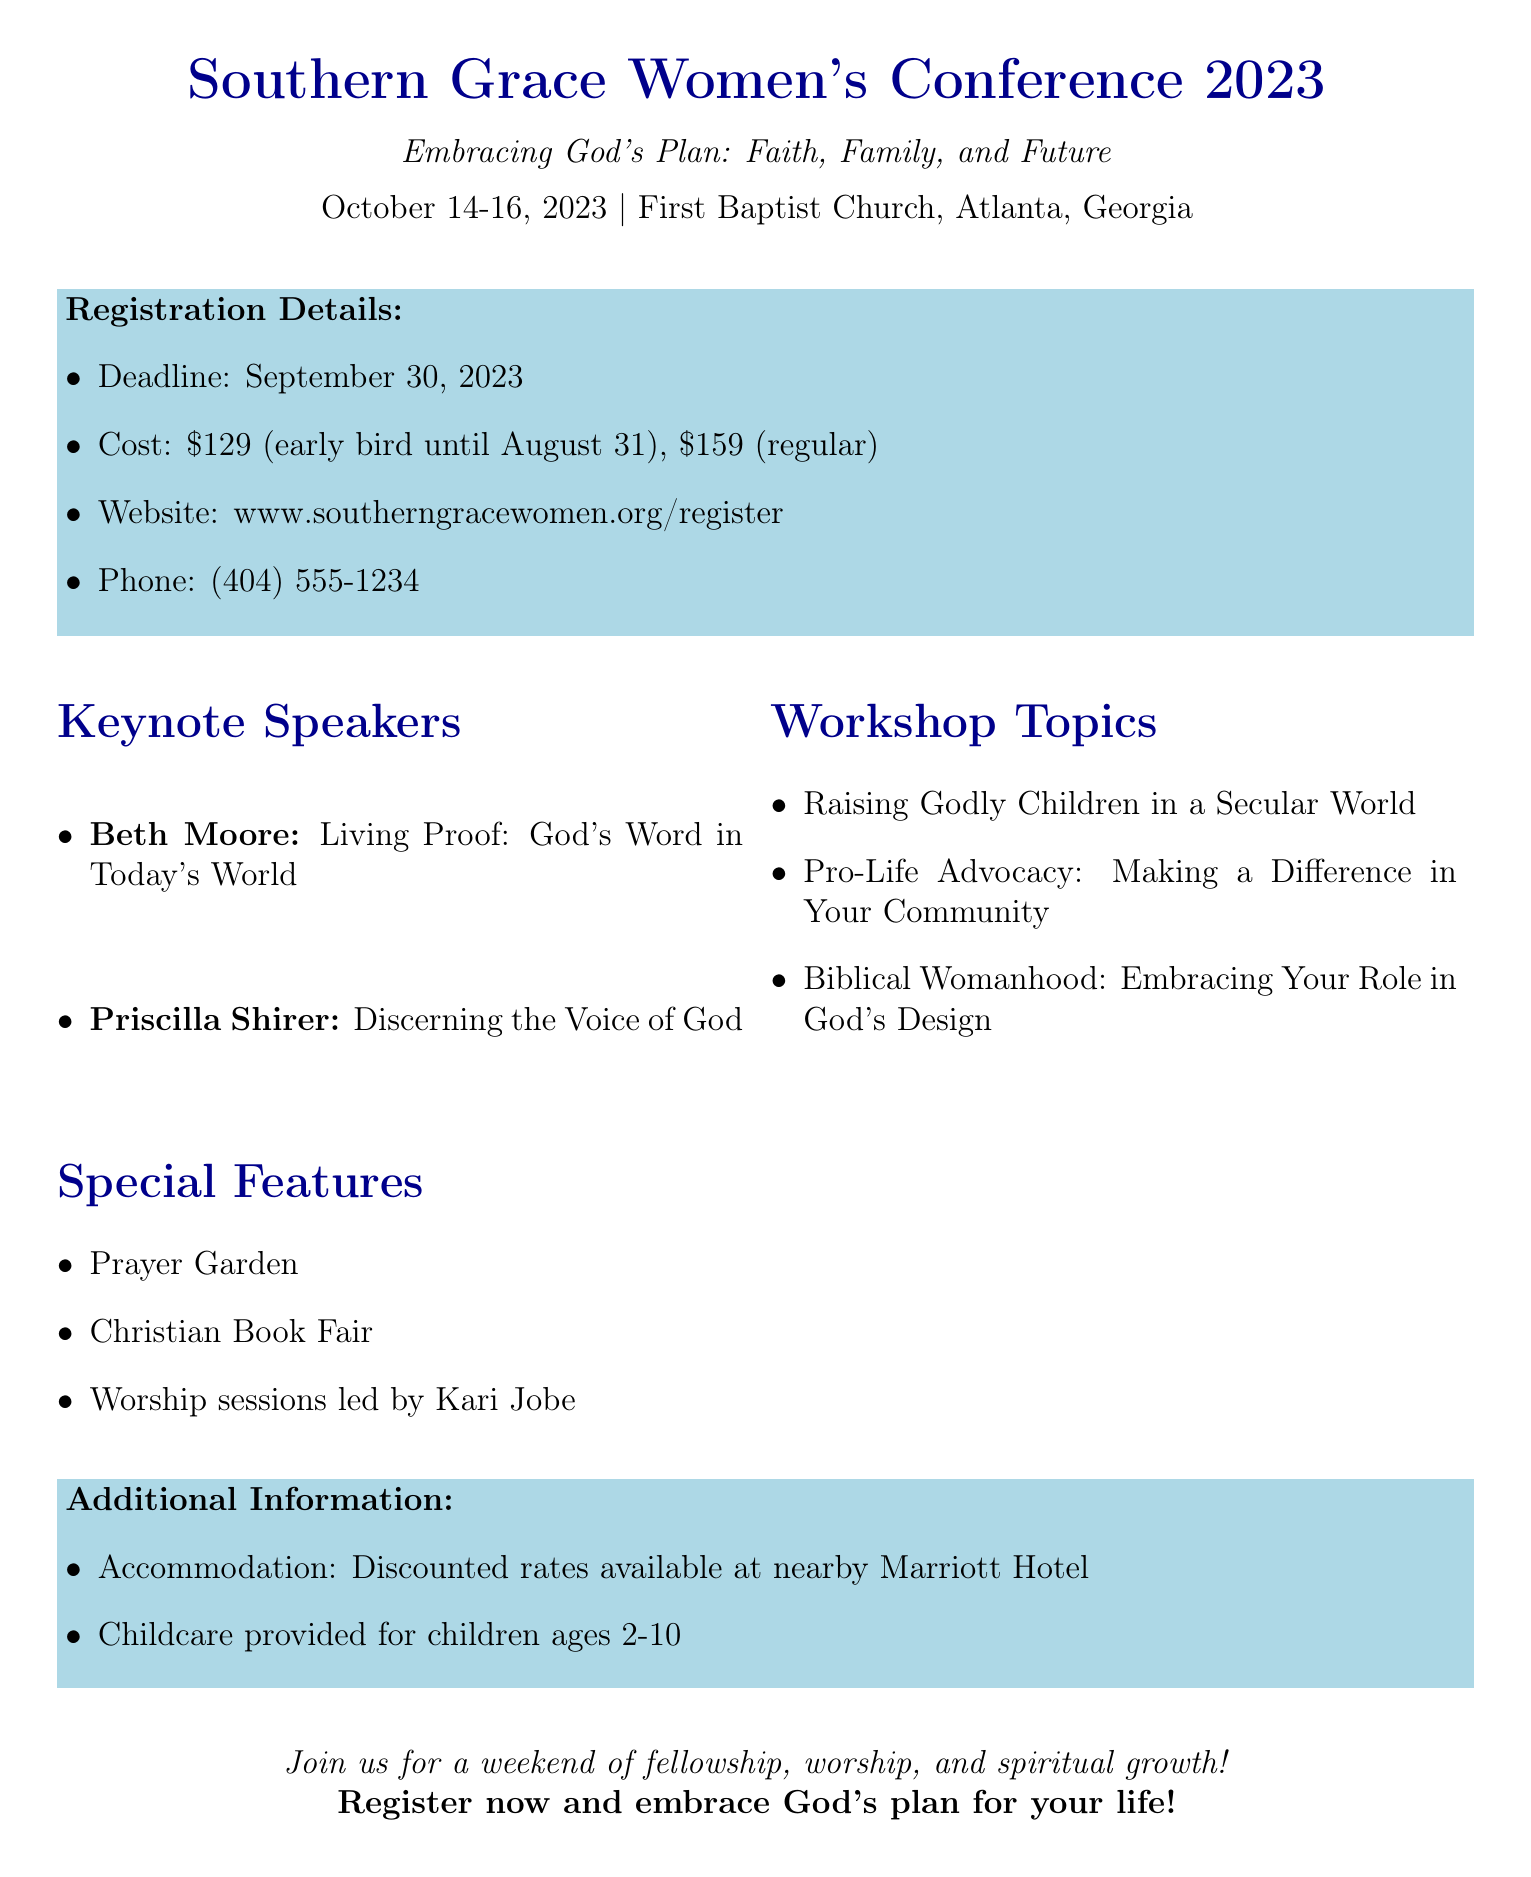What is the event name? The event name is clearly stated at the beginning of the document, which is "Southern Grace Women's Conference 2023."
Answer: Southern Grace Women's Conference 2023 What is the theme of the conference? The theme is provided as a subtitle in the document, which gives insight into the focus of the event.
Answer: Embracing God's Plan: Faith, Family, and Future What are the dates of the conference? The dates are mentioned prominently in the document, indicating when the event will take place.
Answer: October 14-16, 2023 Who is one of the keynote speakers? The document lists the keynote speakers, so this question requires identifying at least one of them.
Answer: Beth Moore What is the cost for early registration? The cost details are specified in the registration section, including the early bird pricing.
Answer: $129 What topics will be addressed in the workshops? The document includes a separate section for workshop topics, requiring recall of one of them.
Answer: Pro-Life Advocacy: Making a Difference in Your Community Where is the conference located? The location is clearly provided in the document, stating where the event will occur.
Answer: First Baptist Church, Atlanta, Georgia What special feature includes worship sessions? The special features section mentions worship sessions led by a specific artist, prompting recall of that detail.
Answer: Worship sessions led by Kari Jobe What is the deadline for registration? The registration deadline is included in the document under registration details.
Answer: September 30, 2023 